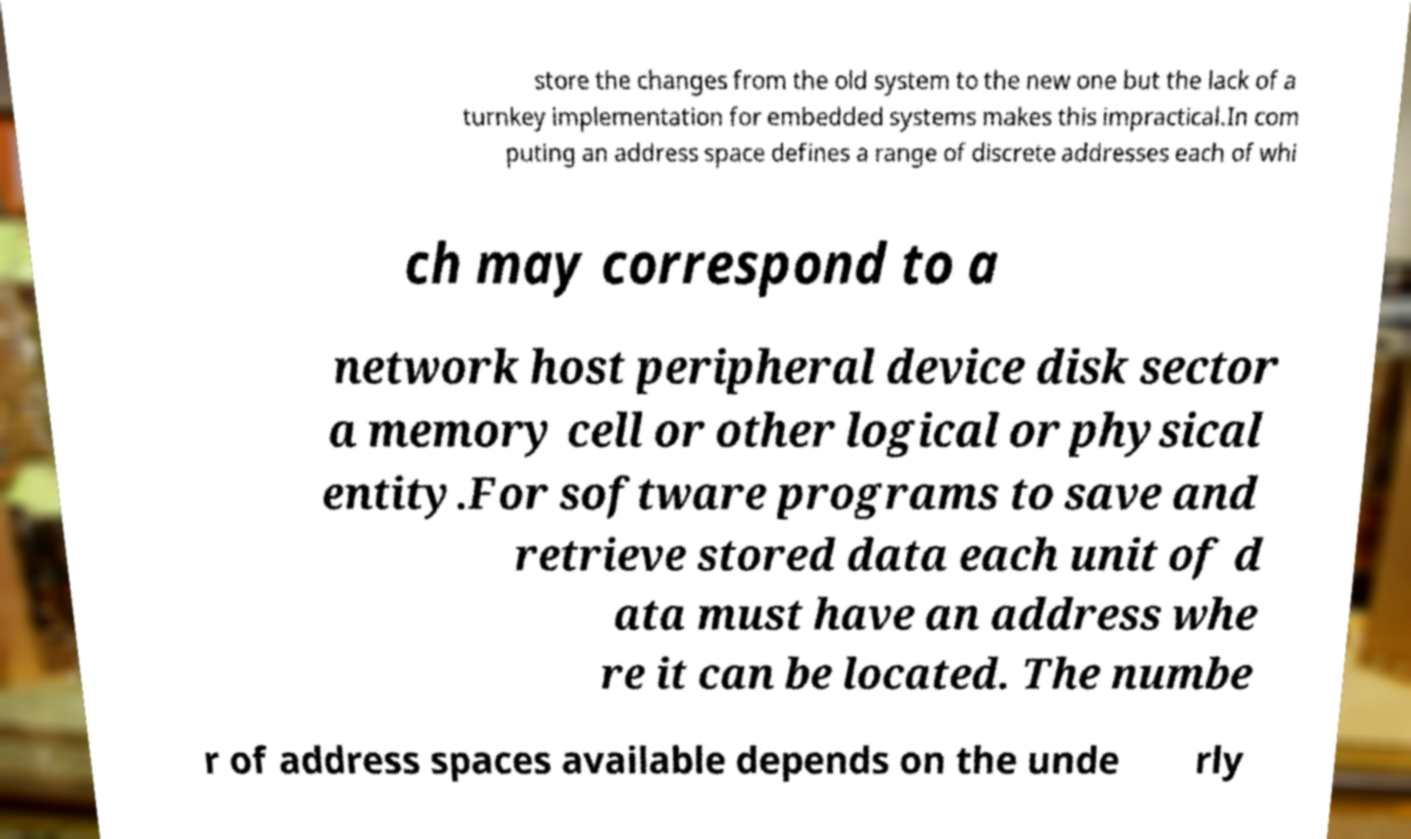Could you assist in decoding the text presented in this image and type it out clearly? store the changes from the old system to the new one but the lack of a turnkey implementation for embedded systems makes this impractical.In com puting an address space defines a range of discrete addresses each of whi ch may correspond to a network host peripheral device disk sector a memory cell or other logical or physical entity.For software programs to save and retrieve stored data each unit of d ata must have an address whe re it can be located. The numbe r of address spaces available depends on the unde rly 